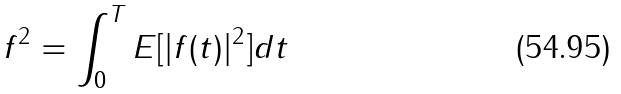<formula> <loc_0><loc_0><loc_500><loc_500>\| f \| ^ { 2 } = \int _ { 0 } ^ { T } E [ | f ( t ) | ^ { 2 } ] d t</formula> 